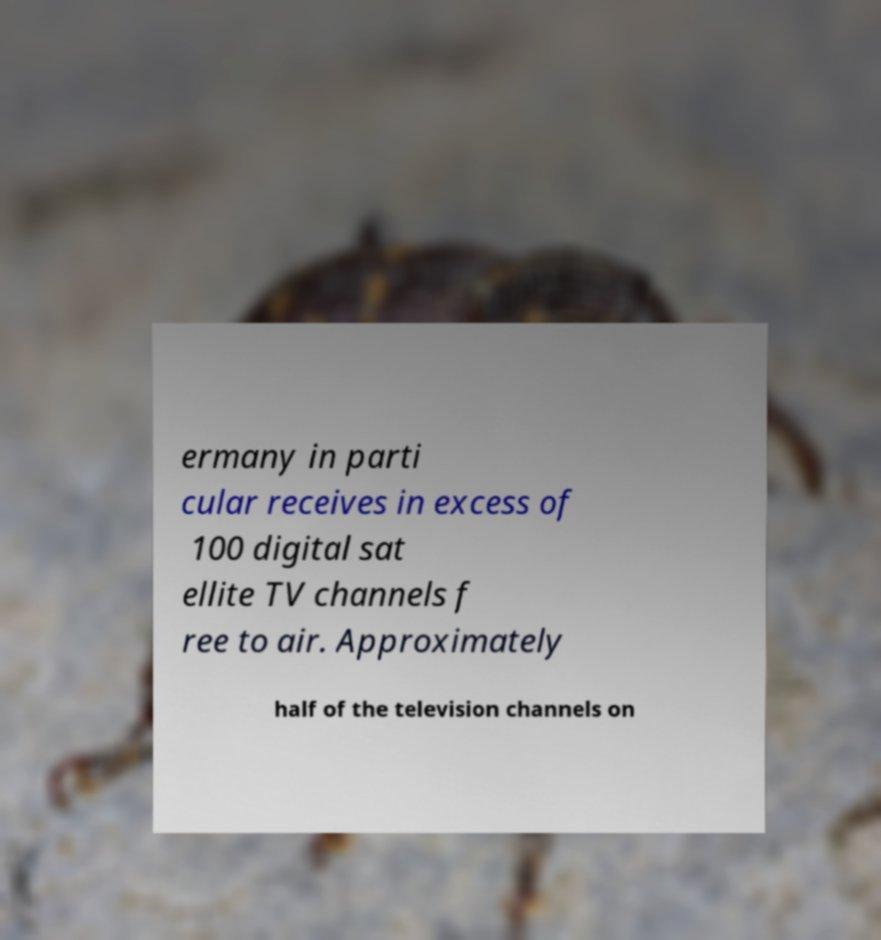Please read and relay the text visible in this image. What does it say? ermany in parti cular receives in excess of 100 digital sat ellite TV channels f ree to air. Approximately half of the television channels on 